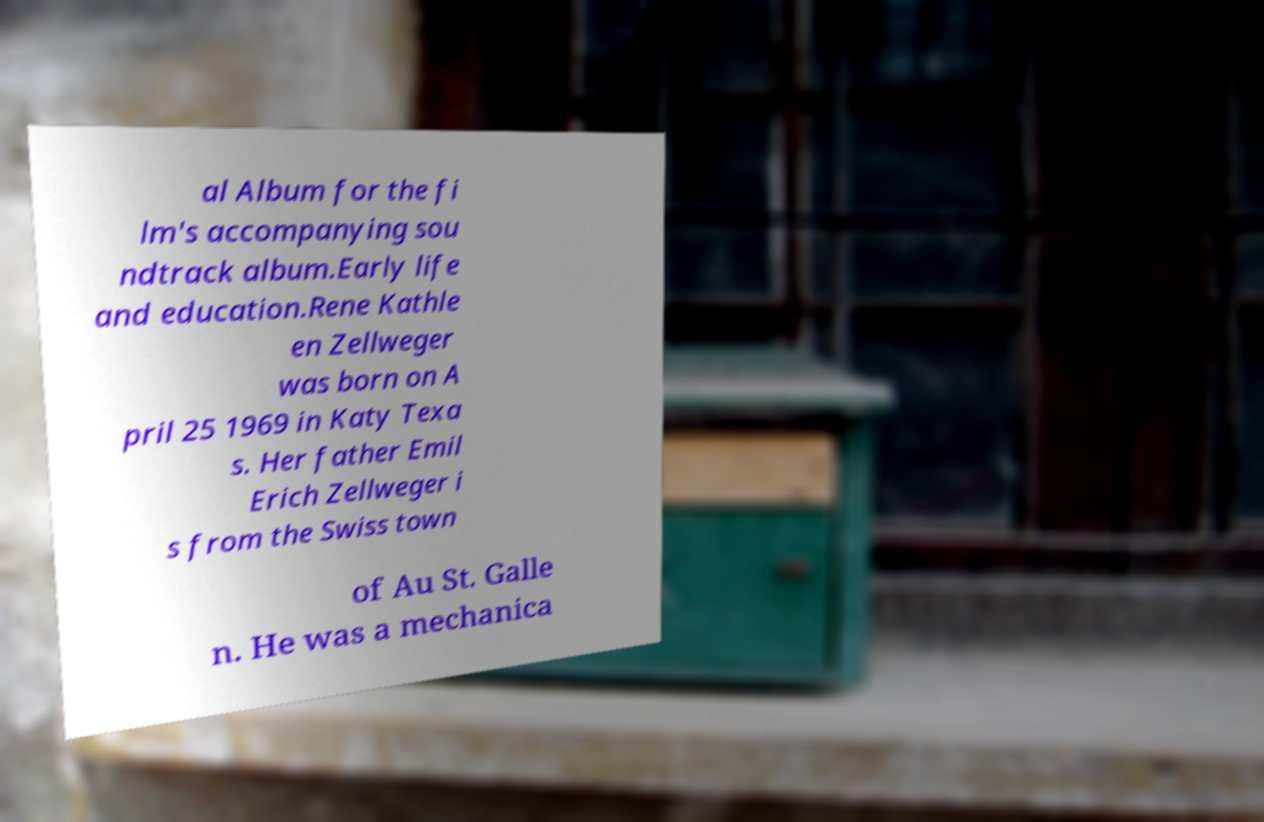What messages or text are displayed in this image? I need them in a readable, typed format. al Album for the fi lm's accompanying sou ndtrack album.Early life and education.Rene Kathle en Zellweger was born on A pril 25 1969 in Katy Texa s. Her father Emil Erich Zellweger i s from the Swiss town of Au St. Galle n. He was a mechanica 